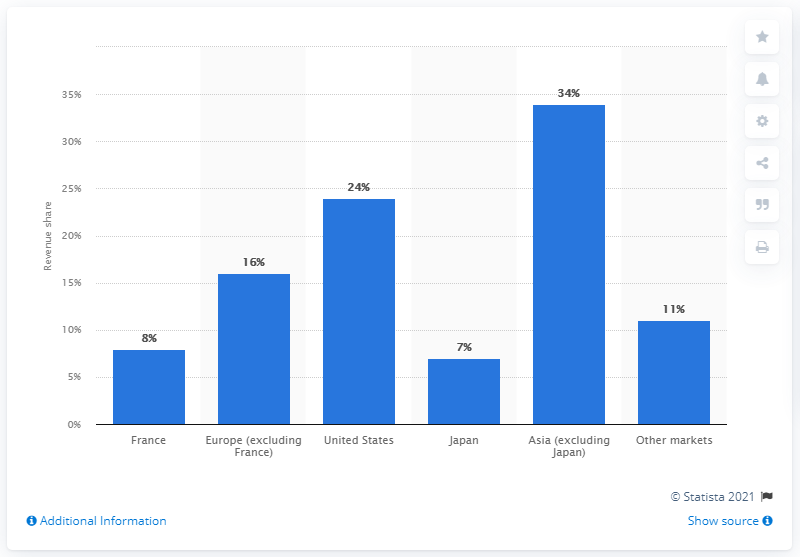Indicate a few pertinent items in this graphic. Dior excludes Japan, the only Asian country from its revenue. Dior reported that approximately 11% of its revenue in the Arabian Gulf region contributed to its overall revenue in the fiscal year. Dior excludes Japan, the only Asian country, from its revenue. 